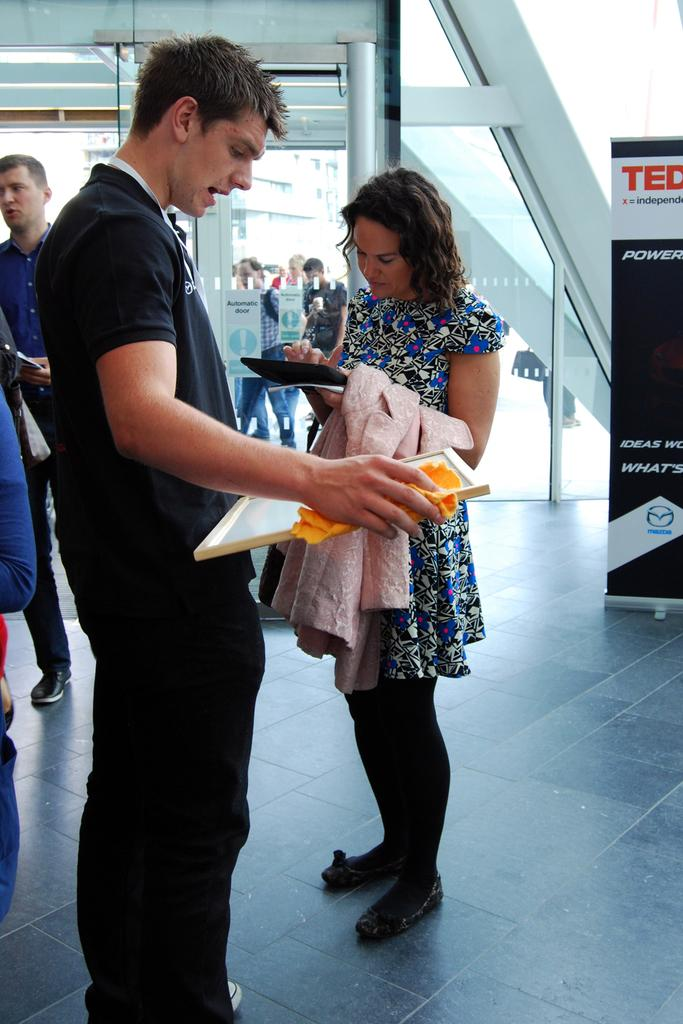What is happening in the image? There are people standing in the image. What can be seen on the right side of the image? There is a banner on the right side of the image. What type of architectural feature is visible in the image? There are glass doors visible in the image. What type of game is being played by the governor in the image? There is no game or governor present in the image. What type of church can be seen in the background of the image? There is no church visible in the image. 